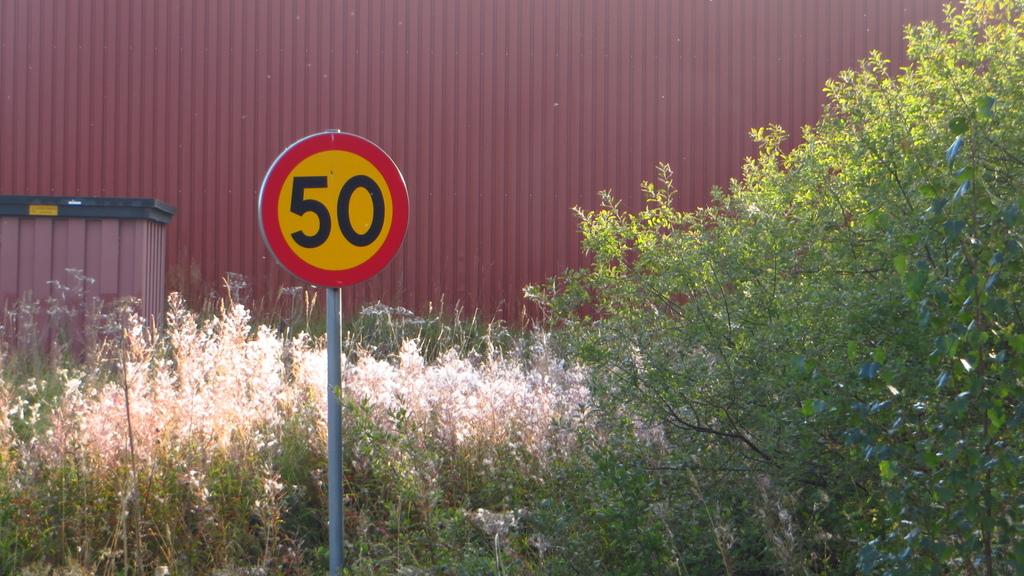What number is on the sign?
Your response must be concise. 50. 